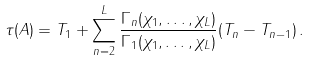Convert formula to latex. <formula><loc_0><loc_0><loc_500><loc_500>\tau ( A ) = T _ { 1 } + \sum _ { n = 2 } ^ { L } \frac { \Gamma _ { n } ( \chi _ { 1 } , \dots , \chi _ { L } ) } { \Gamma _ { 1 } ( \chi _ { 1 } , \dots , \chi _ { L } ) } ( T _ { n } - T _ { n - 1 } ) \, .</formula> 